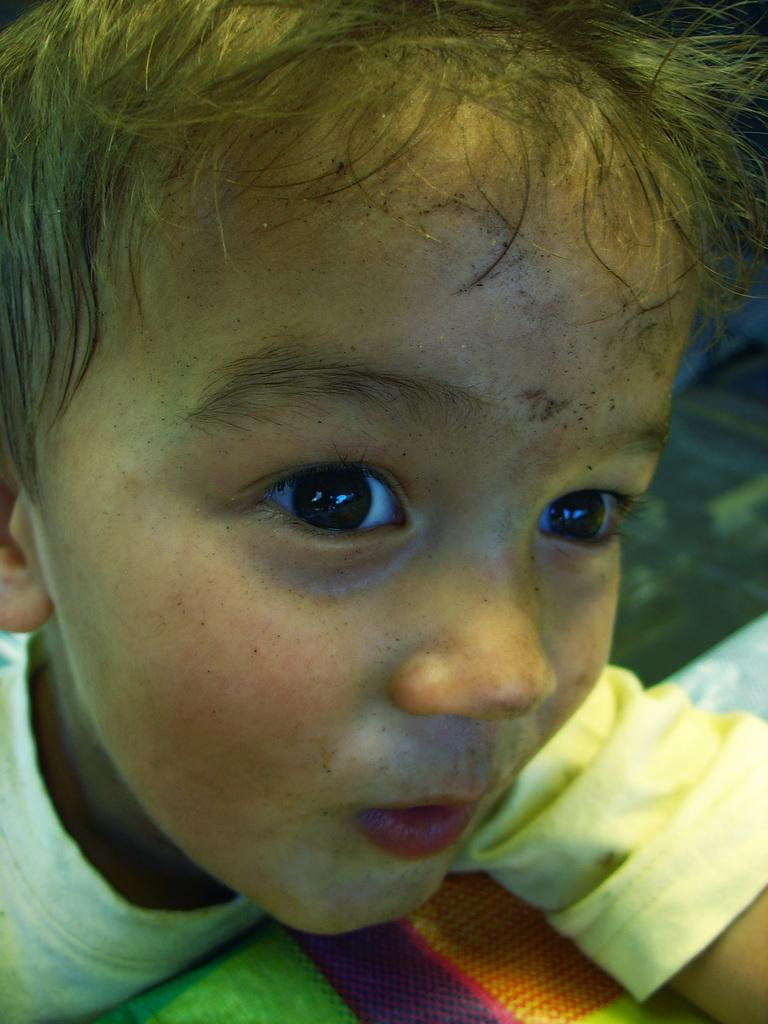What is the main subject of the picture? The main subject of the picture is a boy. What is the boy wearing in the picture? The boy is wearing a t-shirt in the picture. How many edges does the t-shirt have in the image? The t-shirt in the image does not have any visible edges, as it is worn by the boy. 